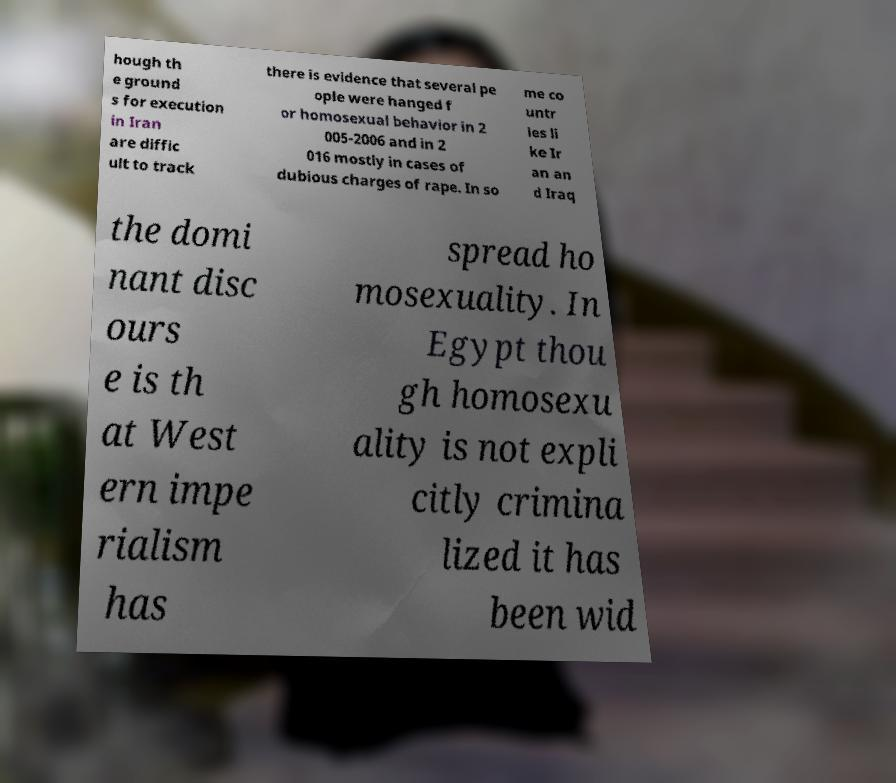Can you accurately transcribe the text from the provided image for me? hough th e ground s for execution in Iran are diffic ult to track there is evidence that several pe ople were hanged f or homosexual behavior in 2 005-2006 and in 2 016 mostly in cases of dubious charges of rape. In so me co untr ies li ke Ir an an d Iraq the domi nant disc ours e is th at West ern impe rialism has spread ho mosexuality. In Egypt thou gh homosexu ality is not expli citly crimina lized it has been wid 